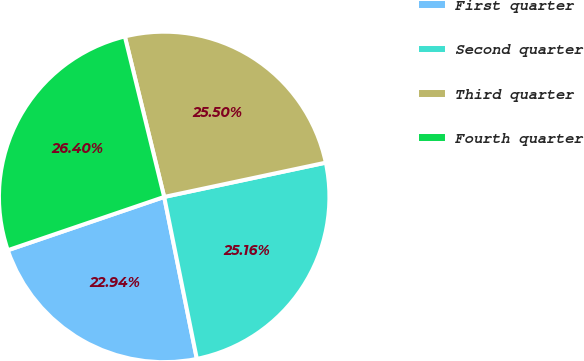Convert chart to OTSL. <chart><loc_0><loc_0><loc_500><loc_500><pie_chart><fcel>First quarter<fcel>Second quarter<fcel>Third quarter<fcel>Fourth quarter<nl><fcel>22.94%<fcel>25.16%<fcel>25.5%<fcel>26.4%<nl></chart> 